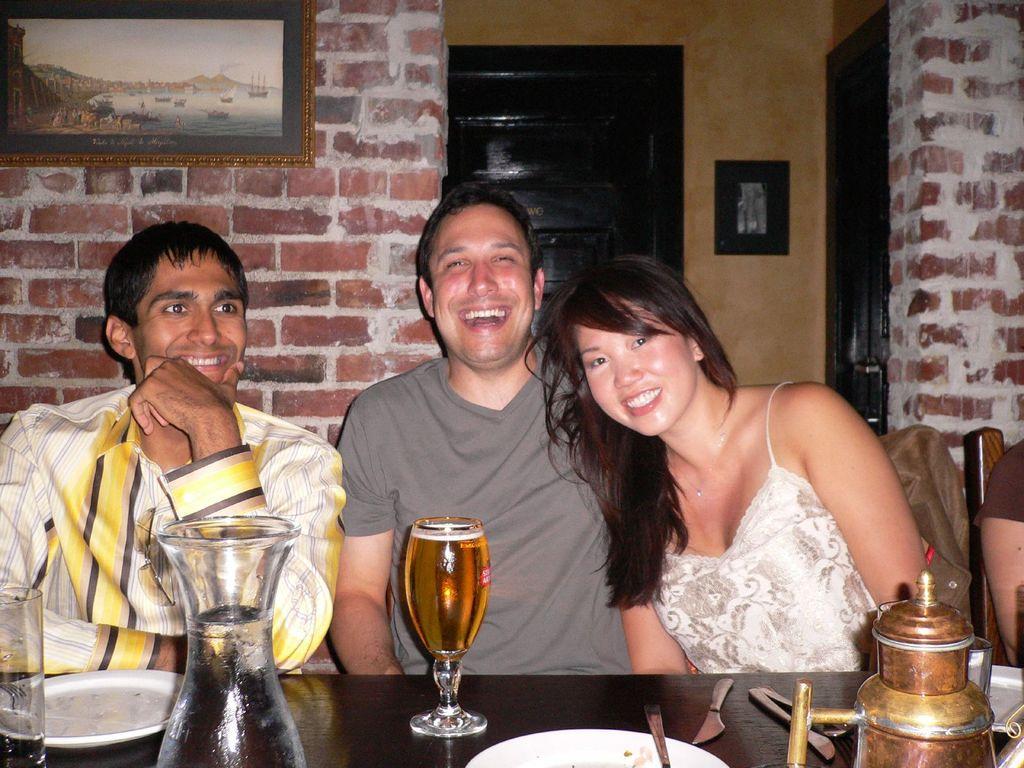Could you give a brief overview of what you see in this image? These people are sitting on chairs and smiling. On this chair there is a jacket. In-front of these people there is a table, on this table we can see plates, glasses, knives and things. Pictures are on the wall. Background we can see brick walls and doors. 